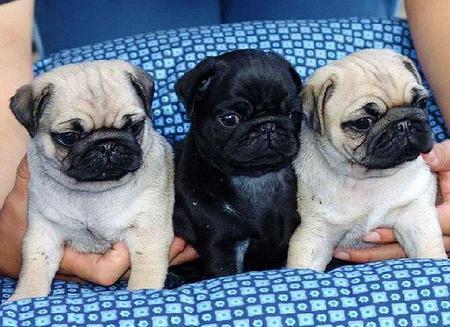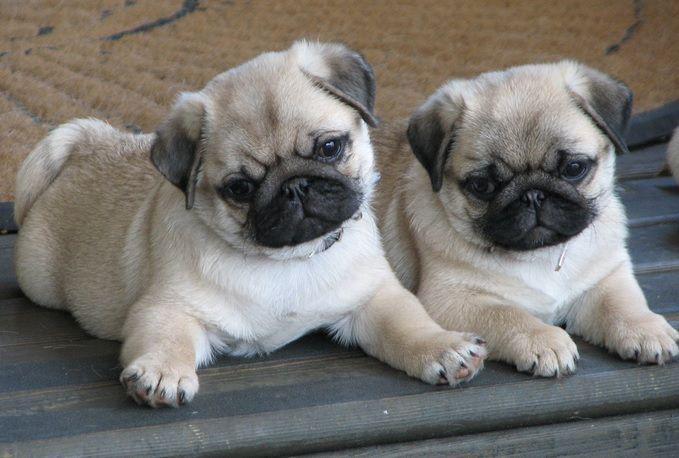The first image is the image on the left, the second image is the image on the right. Evaluate the accuracy of this statement regarding the images: "There are two puppies visible in the image on the right". Is it true? Answer yes or no. Yes. The first image is the image on the left, the second image is the image on the right. Given the left and right images, does the statement "There is two pugs in the right image." hold true? Answer yes or no. Yes. 